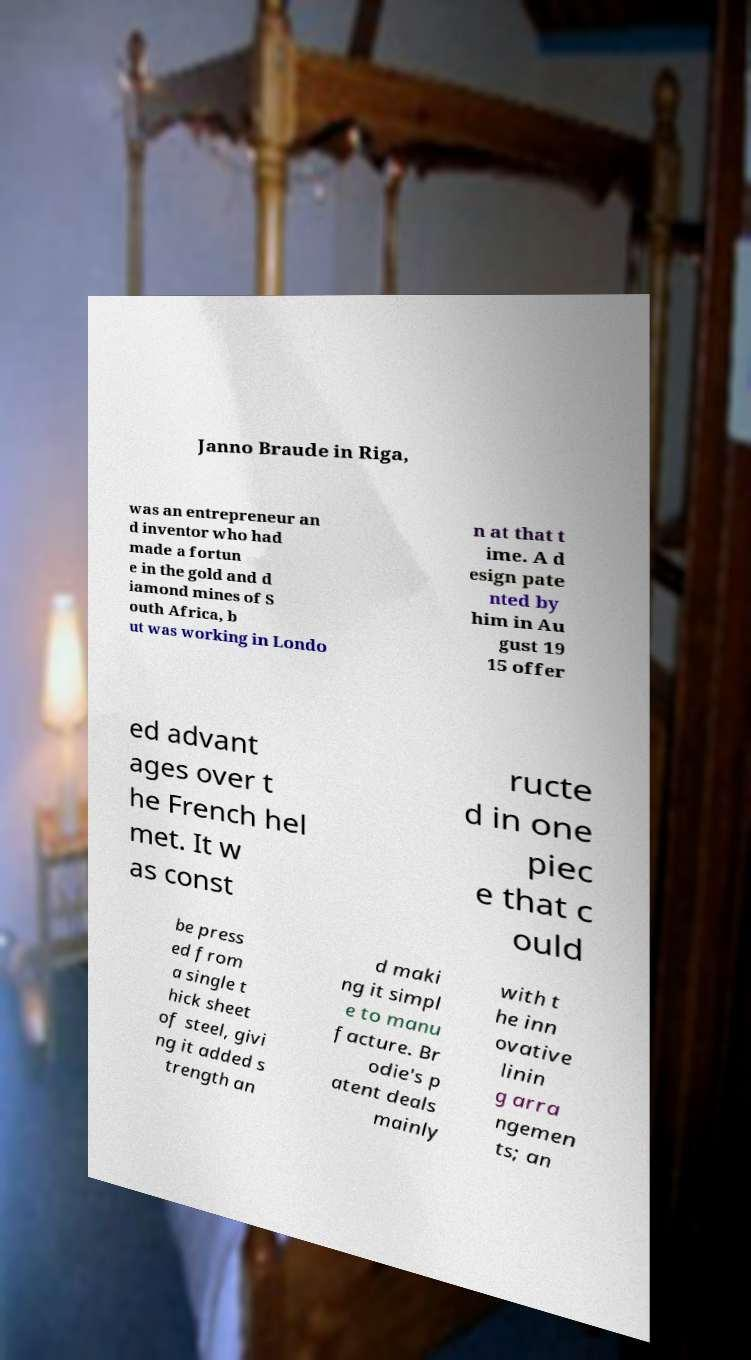I need the written content from this picture converted into text. Can you do that? Janno Braude in Riga, was an entrepreneur an d inventor who had made a fortun e in the gold and d iamond mines of S outh Africa, b ut was working in Londo n at that t ime. A d esign pate nted by him in Au gust 19 15 offer ed advant ages over t he French hel met. It w as const ructe d in one piec e that c ould be press ed from a single t hick sheet of steel, givi ng it added s trength an d maki ng it simpl e to manu facture. Br odie's p atent deals mainly with t he inn ovative linin g arra ngemen ts; an 